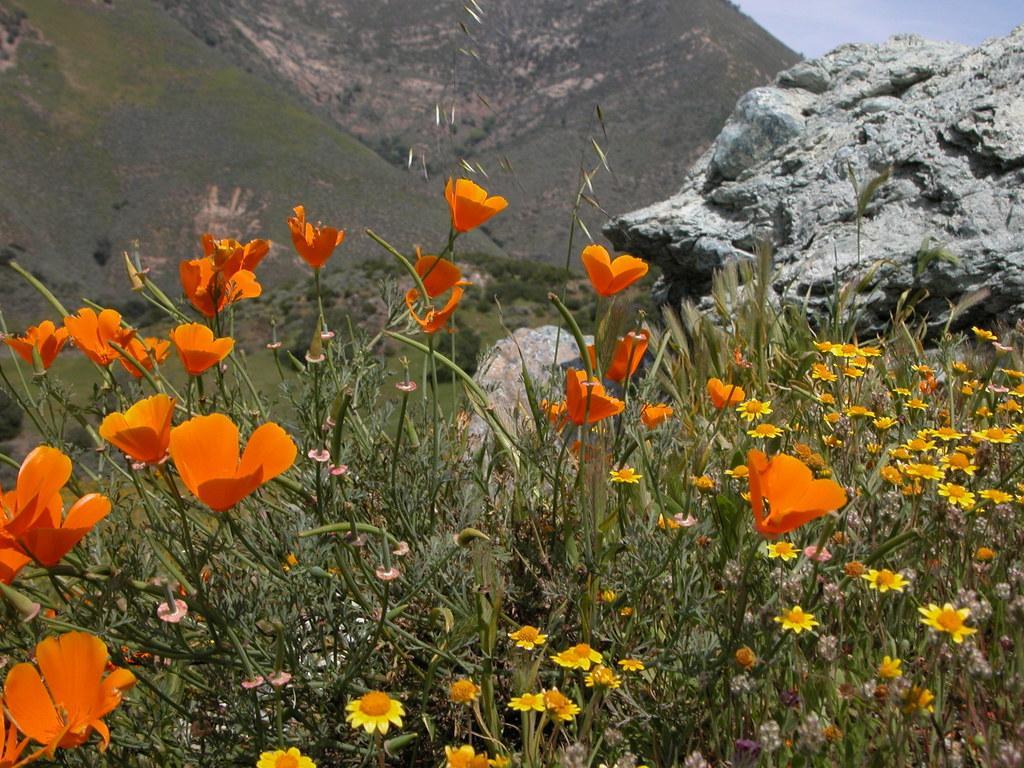Describe this image in one or two sentences. We can see colorful flowers and plants. In the background we can see hills and sky. 